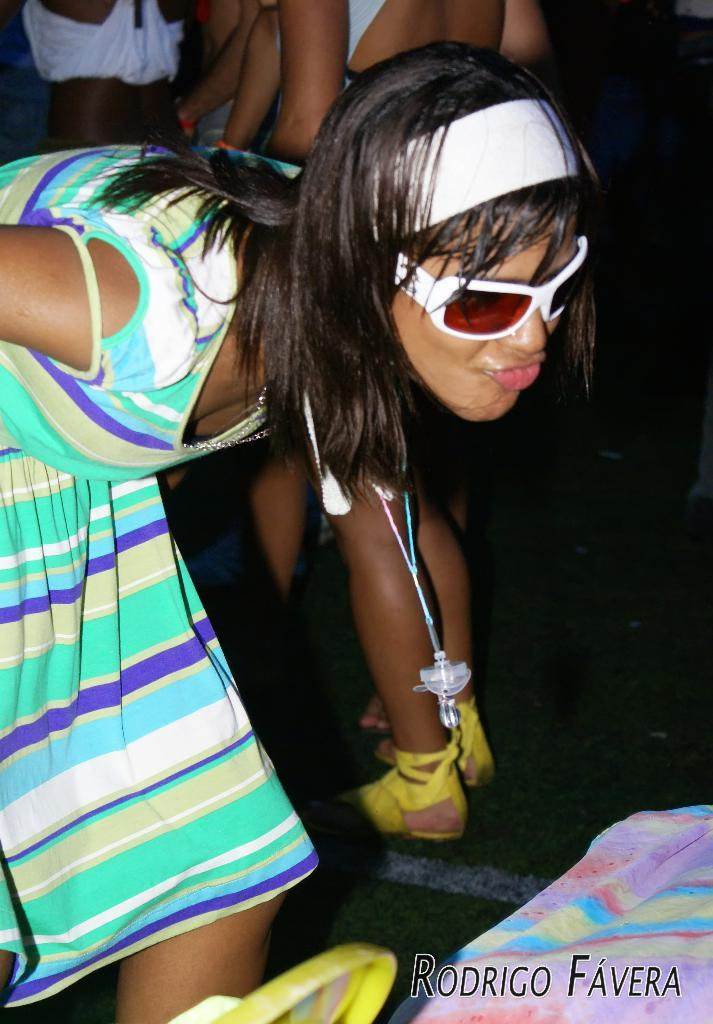Who is the main subject in the image? There is a woman in the image. What is the woman wearing? The woman is wearing a multi-color dress, shades, and a headband. What is the woman doing in the image? The woman is bending. Are there any other people visible in the image? Yes, there are persons standing in the background of the image. What type of basin is the woman using to wash her hair in the image? There is no basin present in the image, and the woman is not washing her hair. What is the woman doing with the sponge in the image? There is no sponge present in the image. 